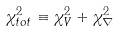<formula> <loc_0><loc_0><loc_500><loc_500>\chi ^ { 2 } _ { t o t } \equiv \chi ^ { 2 } _ { V } + \chi ^ { 2 } _ { \nabla }</formula> 